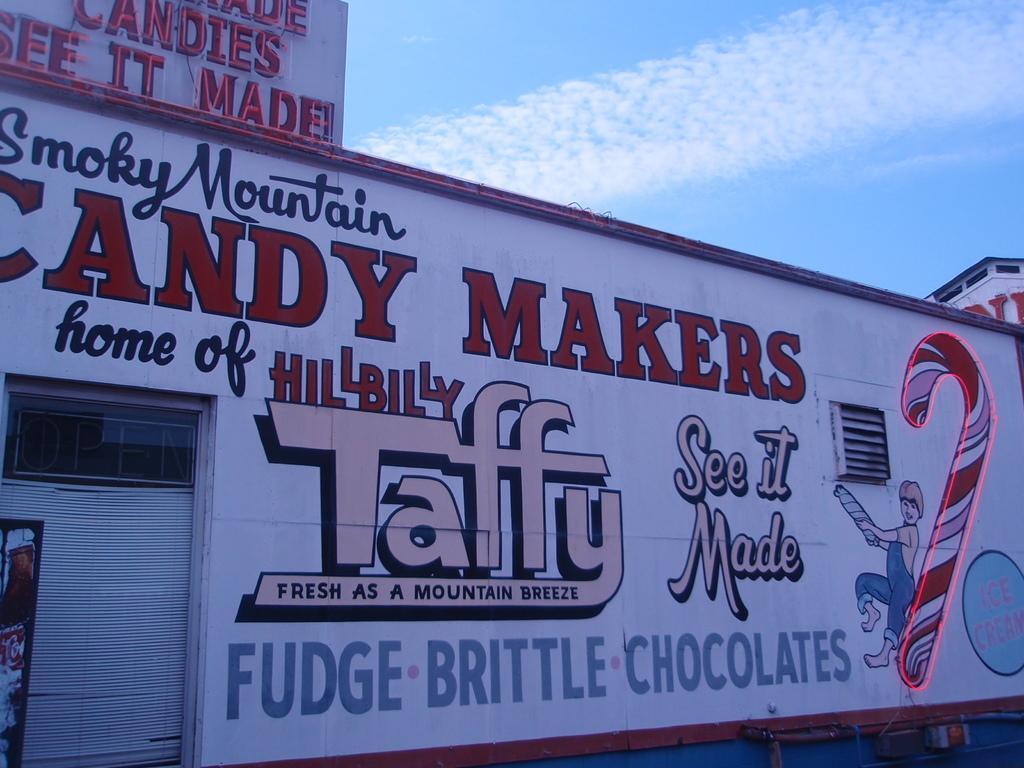Could you give a brief overview of what you see in this image? In the foreground of the picture there is a wall, on the wall there is text. On the left there is a door. Sky is sunny. 